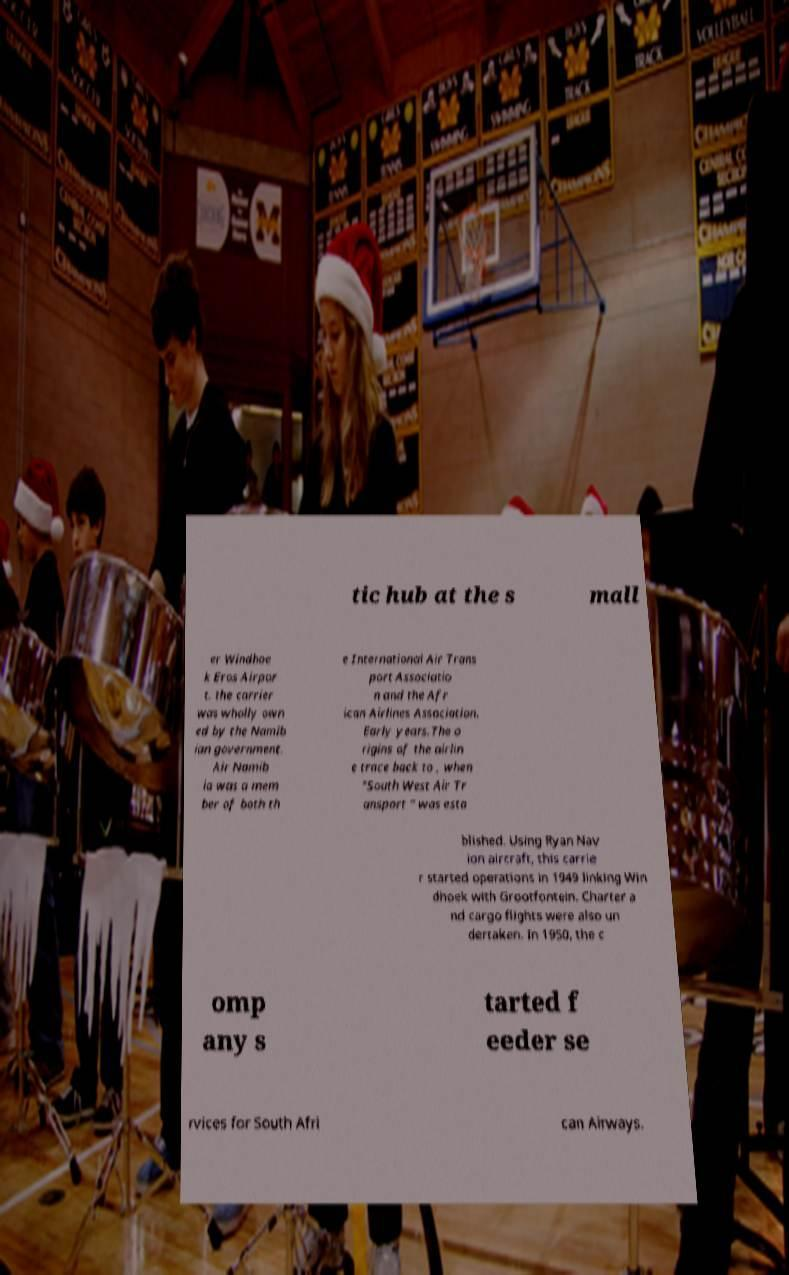Please read and relay the text visible in this image. What does it say? tic hub at the s mall er Windhoe k Eros Airpor t. the carrier was wholly own ed by the Namib ian government. Air Namib ia was a mem ber of both th e International Air Trans port Associatio n and the Afr ican Airlines Association. Early years.The o rigins of the airlin e trace back to , when "South West Air Tr ansport " was esta blished. Using Ryan Nav ion aircraft, this carrie r started operations in 1949 linking Win dhoek with Grootfontein. Charter a nd cargo flights were also un dertaken. In 1950, the c omp any s tarted f eeder se rvices for South Afri can Airways. 